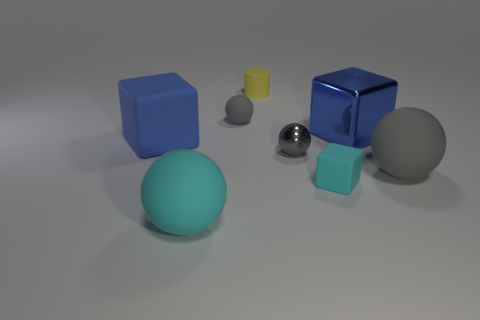Subtract all tiny cubes. How many cubes are left? 2 Add 1 small shiny blocks. How many objects exist? 9 Subtract all cyan cubes. How many cubes are left? 2 Subtract all gray balls. Subtract all red cubes. How many balls are left? 1 Subtract all brown cubes. How many cyan balls are left? 1 Subtract all matte balls. Subtract all big blue shiny objects. How many objects are left? 4 Add 3 tiny balls. How many tiny balls are left? 5 Add 7 purple rubber cylinders. How many purple rubber cylinders exist? 7 Subtract 0 purple cubes. How many objects are left? 8 Subtract all cubes. How many objects are left? 5 